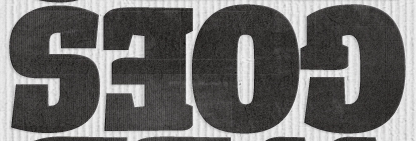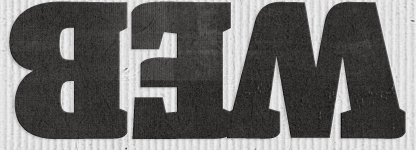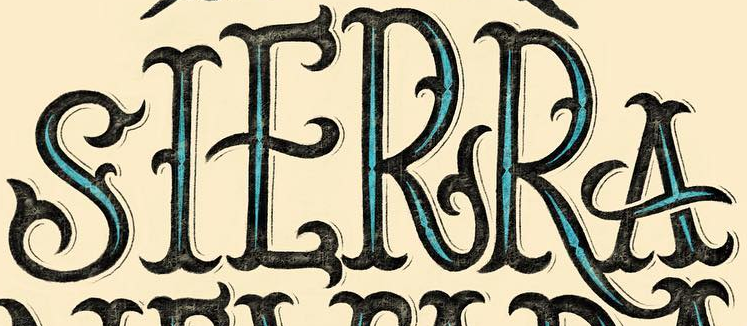What text is displayed in these images sequentially, separated by a semicolon? GOES; WEB; SIERRA 